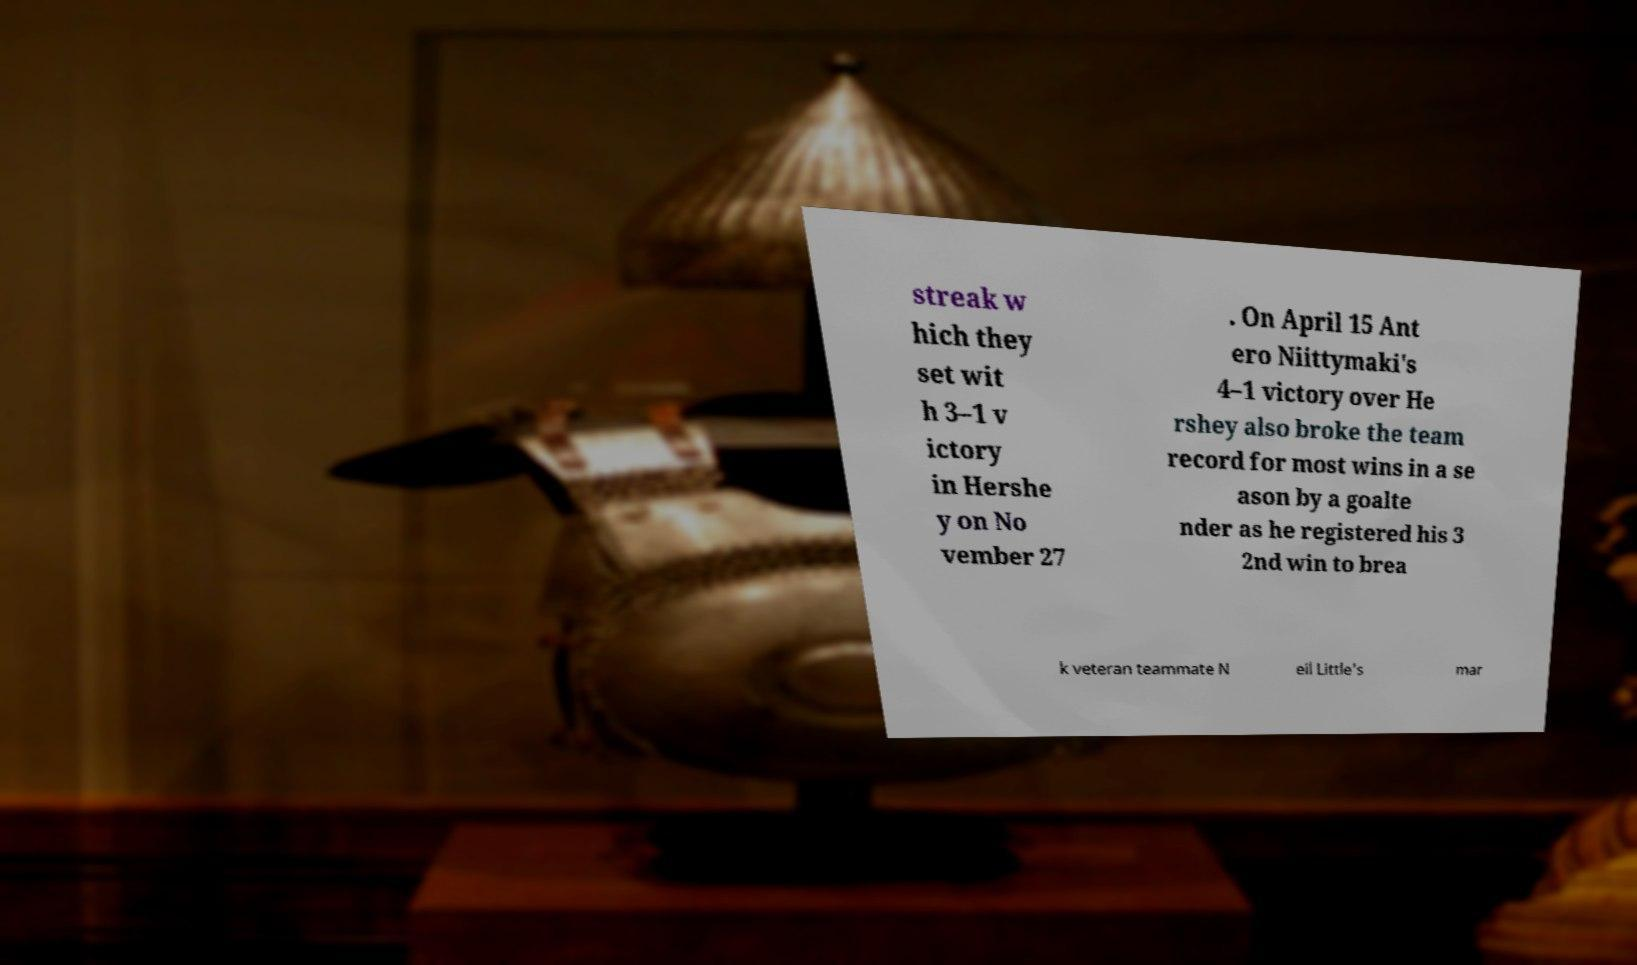What messages or text are displayed in this image? I need them in a readable, typed format. streak w hich they set wit h 3–1 v ictory in Hershe y on No vember 27 . On April 15 Ant ero Niittymaki's 4–1 victory over He rshey also broke the team record for most wins in a se ason by a goalte nder as he registered his 3 2nd win to brea k veteran teammate N eil Little's mar 